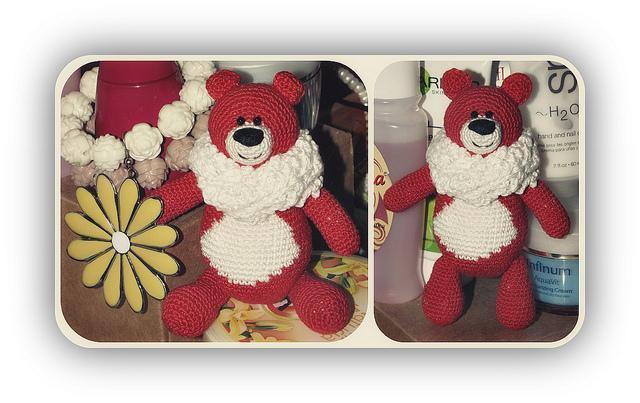How many teddy bears are there?
Give a very brief answer. 2. How many of the train carts have red around the windows?
Give a very brief answer. 0. 